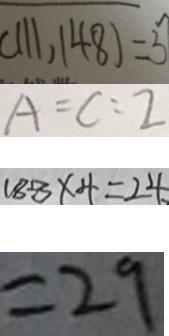Convert formula to latex. <formula><loc_0><loc_0><loc_500><loc_500>( 1 1 1 , 1 4 8 ) = 3 7 
 A = C : 2 
 1 8 8 \times 4 = 2 4 
 = 2 9</formula> 